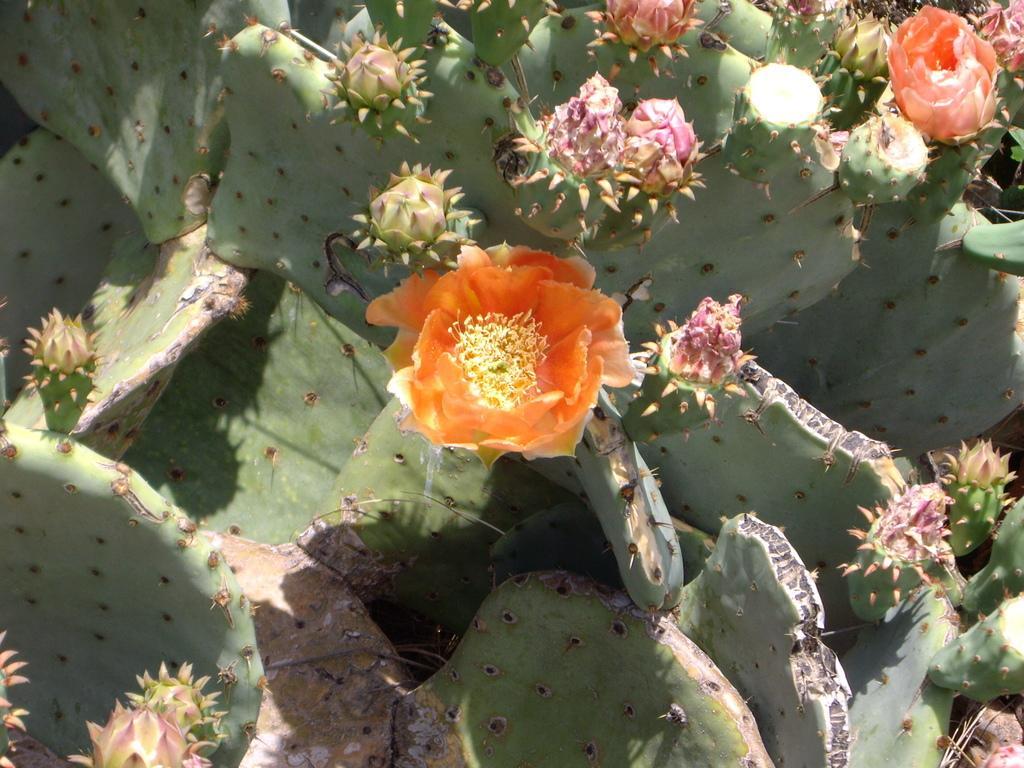Can you describe this image briefly? In this picture there are few flowers and there is cactus plant below it. 